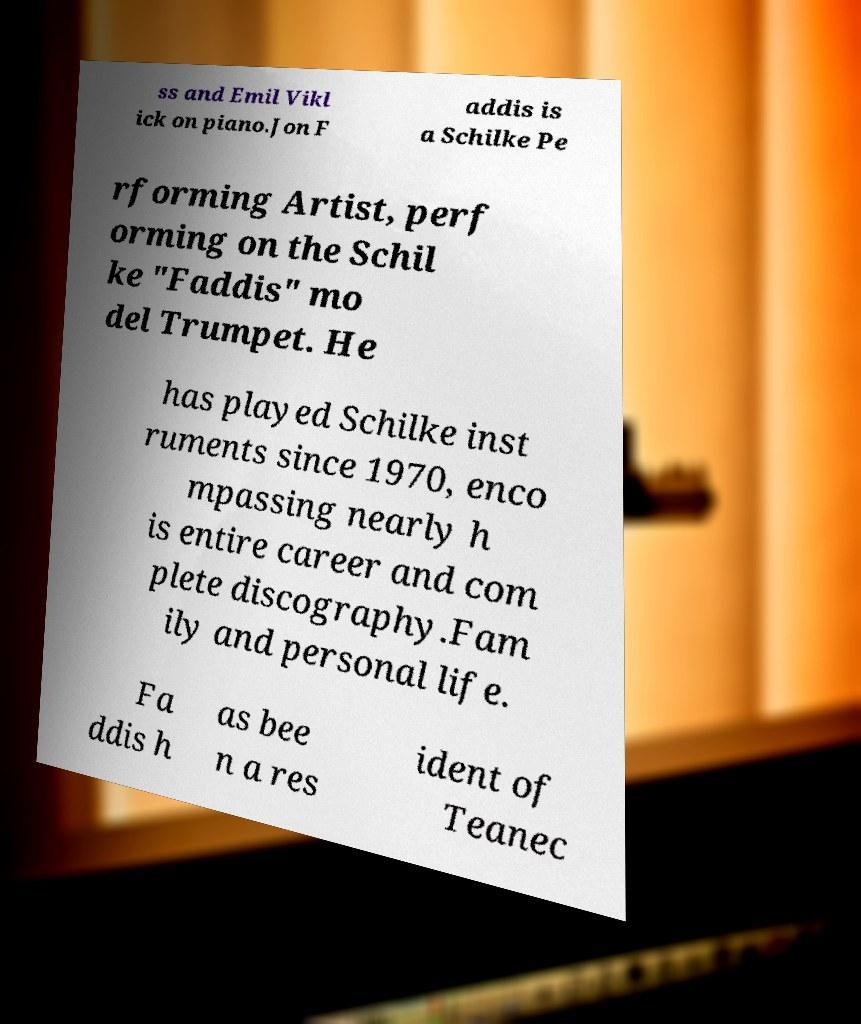Please identify and transcribe the text found in this image. ss and Emil Vikl ick on piano.Jon F addis is a Schilke Pe rforming Artist, perf orming on the Schil ke "Faddis" mo del Trumpet. He has played Schilke inst ruments since 1970, enco mpassing nearly h is entire career and com plete discography.Fam ily and personal life. Fa ddis h as bee n a res ident of Teanec 